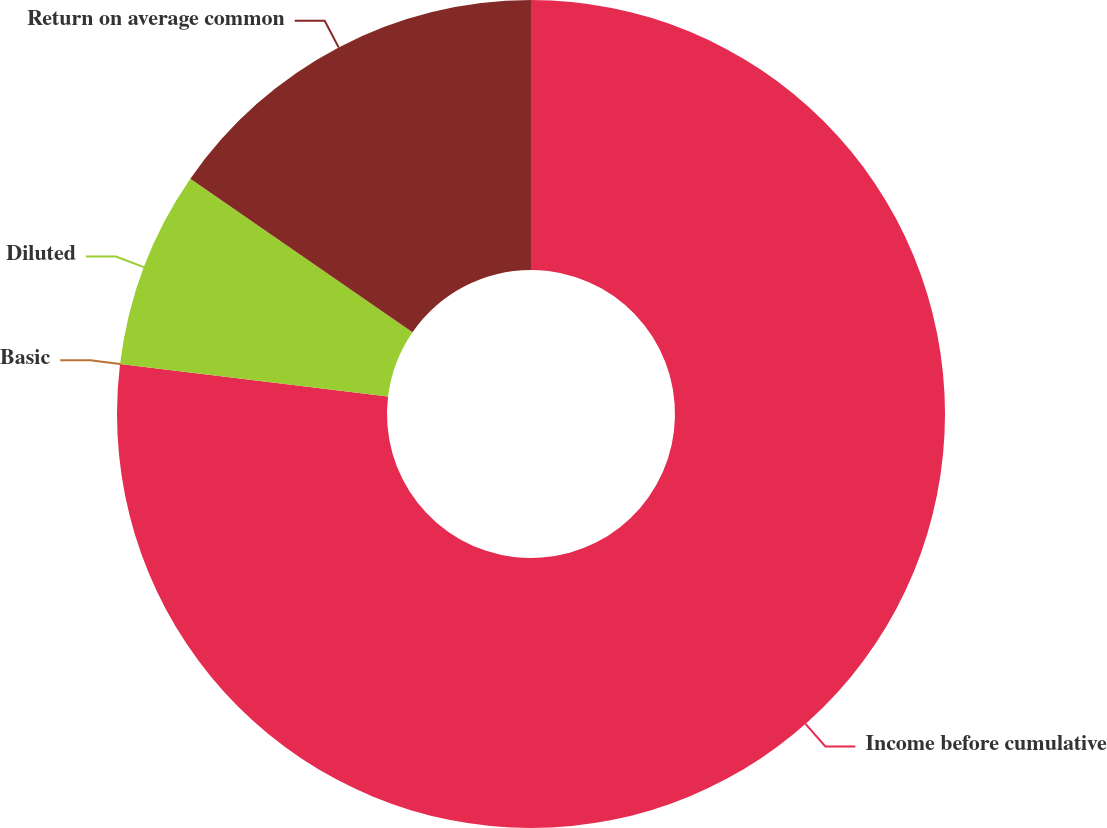Convert chart. <chart><loc_0><loc_0><loc_500><loc_500><pie_chart><fcel>Income before cumulative<fcel>Basic<fcel>Diluted<fcel>Return on average common<nl><fcel>76.92%<fcel>0.0%<fcel>7.69%<fcel>15.38%<nl></chart> 